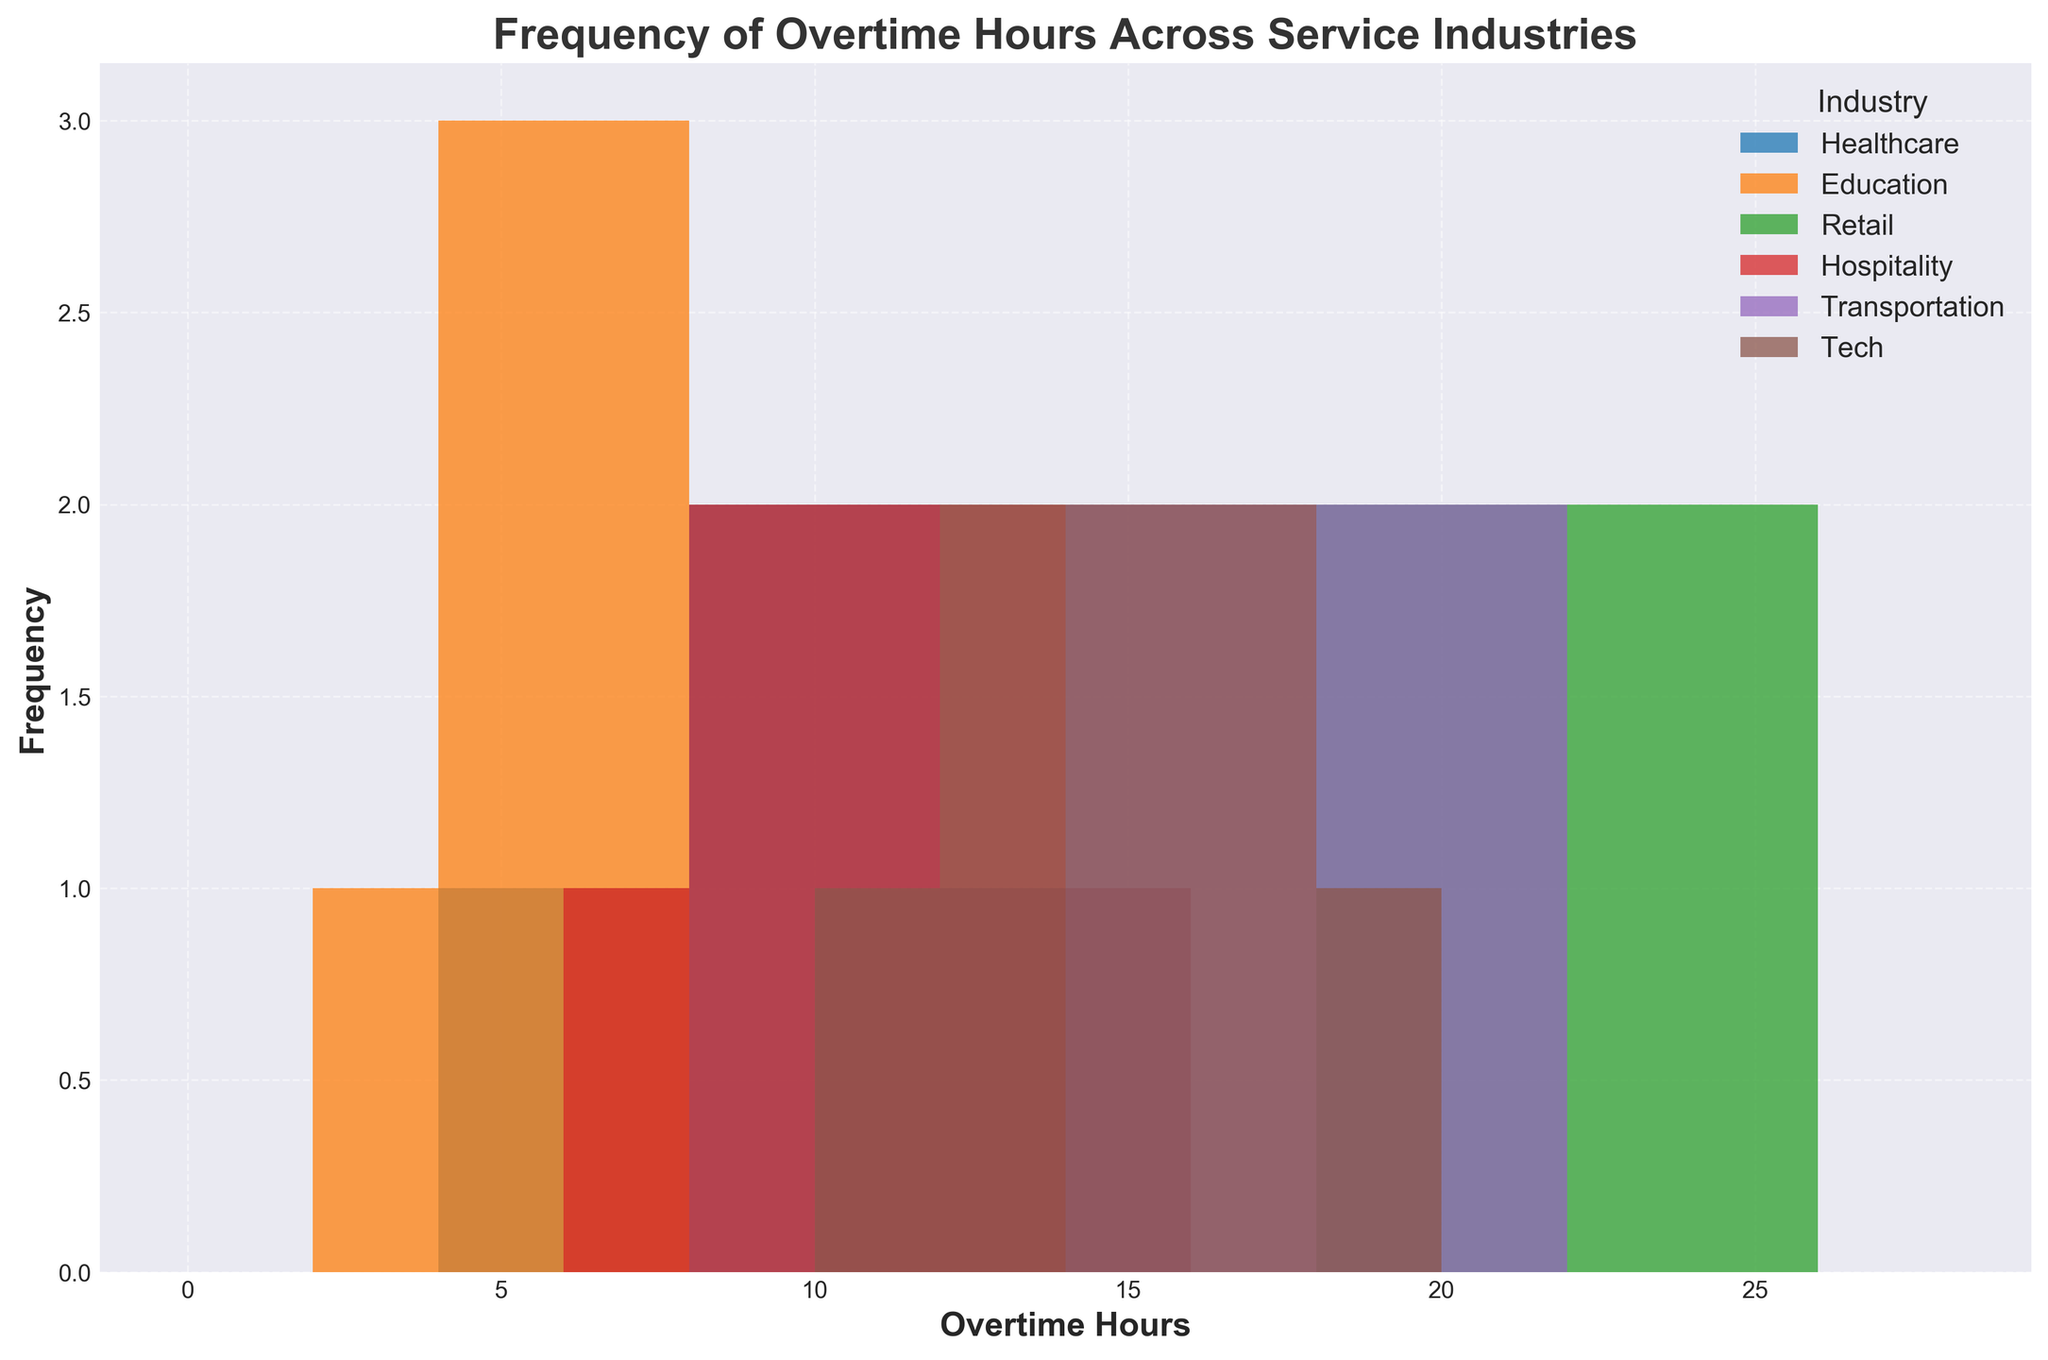what is the industry with the highest frequency of 10-12 overtime hours combined? To find the industry with the highest frequency of combined 10-12 overtime hours, we look at the height of the bars spanning the range 10-12. In this range, Healthcare, Hospitality, Tech, and Transportation have visible bars. Summing the heights of these bars, Hospitality seems to have the tallest combined bars in this range.
Answer: Hospitality Which industry has the widest spread of overtime hours? To determine the industry with the widest spread of overtime hours, compare the range of values on the x-axis for each industry. Retail spans the widest range from 18 to 25 overtime hours.
Answer: Retail What is the approximate range of overtime hours in the transportation industry? Look for the minimum and maximum values on the x-axis for the Transportation industry. Transportation data spans from 14 to 21 overtime hours.
Answer: 14-21 Which industry has the highest peak frequency and at what overtime hours? Identify the highest bar in the histogram and then check its label and x-axis value. Retail has the highest peak frequency, which is around 20-24 overtime hours.
Answer: Retail, 20-24 How does the frequency of overtime hours in Tech compare to Healthcare at the 10-hour mark? For comparison, check the height of the bars in the Tech and Healthcare industries at the 10-hour mark. Both Tech and Healthcare have equal frequency at this specific mark.
Answer: Equal Calculate the average range of overtime hours in the education industry. To find the average range, sum the lowest and highest overtime hours and divide by 2. Education spans from 3 to 7 overtime hours. Average = (3 + 7)/2 = 5
Answer: 5 Which industry shows the lowest variability in overtime hours? Assess which industry has bars clustered closely together within a narrow range. Education has its bars clustered within the range of 3-7 overtime hours, indicating low variability.
Answer: Education Which industry shows the most even distribution of overtime hours? Look for an industry where the bars are relatively even in height and spread evenly across a range. Hospitality appears to have a relatively even distribution across its range of 7-14 overtime hours.
Answer: Hospitality Approximately how many bars are between the ranges of 6-8 overtime hours in the education industry? Count the visible bars or frequencies within the range of 6-8 for the Education industry. We notice that there are two bars in this range.
Answer: 2 